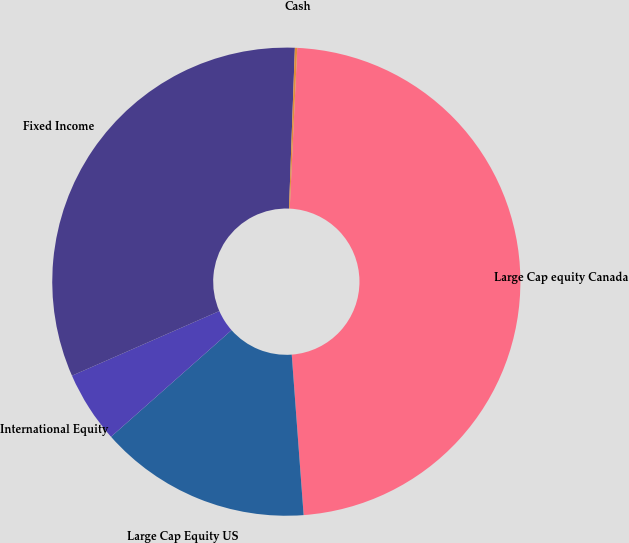Convert chart to OTSL. <chart><loc_0><loc_0><loc_500><loc_500><pie_chart><fcel>Large Cap equity Canada<fcel>Large Cap Equity US<fcel>International Equity<fcel>Fixed Income<fcel>Cash<nl><fcel>48.08%<fcel>14.65%<fcel>4.95%<fcel>32.16%<fcel>0.16%<nl></chart> 